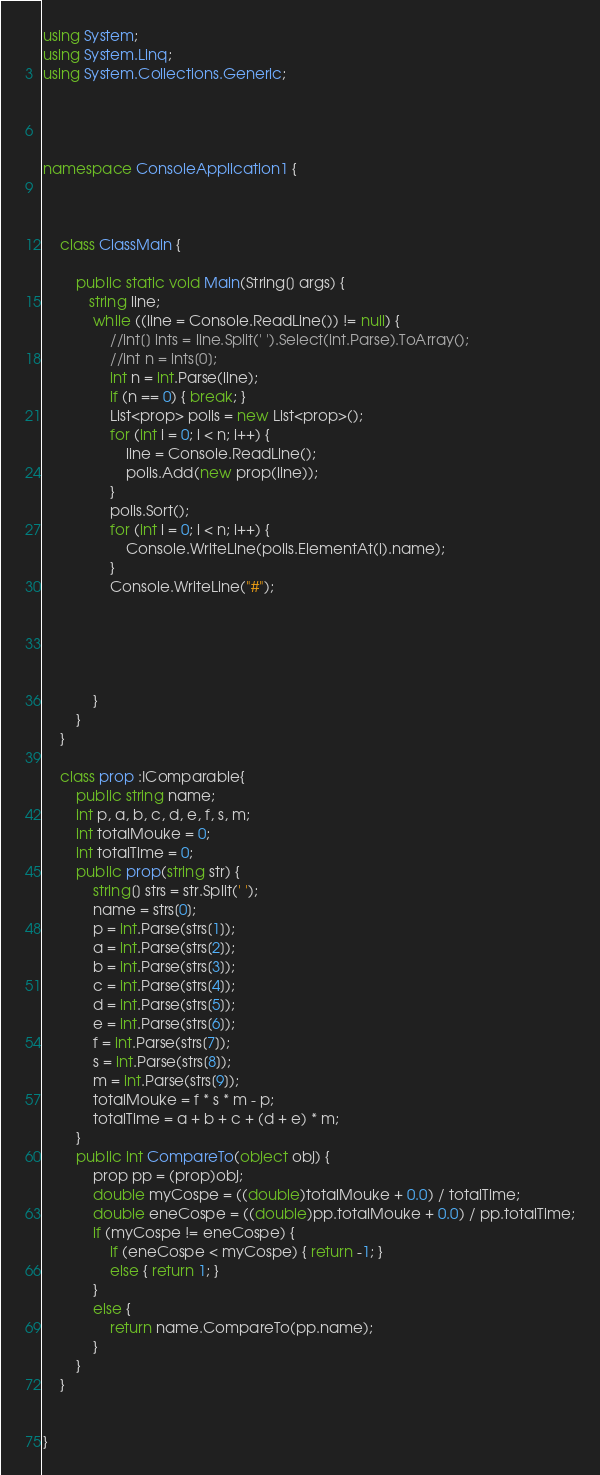Convert code to text. <code><loc_0><loc_0><loc_500><loc_500><_C#_>using System;
using System.Linq;
using System.Collections.Generic;




namespace ConsoleApplication1 {

    

    class ClassMain {

        public static void Main(String[] args) {
           string line;
            while ((line = Console.ReadLine()) != null) {
                //int[] ints = line.Split(' ').Select(int.Parse).ToArray();
                //int n = ints[0];
                int n = int.Parse(line);                
                if (n == 0) { break; }
                List<prop> polis = new List<prop>();
                for (int i = 0; i < n; i++) {
                    line = Console.ReadLine();
                    polis.Add(new prop(line));
                }
                polis.Sort();
                for (int i = 0; i < n; i++) {
                    Console.WriteLine(polis.ElementAt(i).name);
                }
                Console.WriteLine("#");
                    
                



            }
        }
    }

    class prop :IComparable{
        public string name;
        int p, a, b, c, d, e, f, s, m;
        int totalMouke = 0;
        int totalTime = 0;
        public prop(string str) {
            string[] strs = str.Split(' ');
            name = strs[0];
            p = int.Parse(strs[1]);
            a = int.Parse(strs[2]);
            b = int.Parse(strs[3]);
            c = int.Parse(strs[4]);
            d = int.Parse(strs[5]);
            e = int.Parse(strs[6]);
            f = int.Parse(strs[7]);
            s = int.Parse(strs[8]);
            m = int.Parse(strs[9]);
            totalMouke = f * s * m - p;
            totalTime = a + b + c + (d + e) * m;
        }
        public int CompareTo(object obj) {
            prop pp = (prop)obj;
            double myCospe = ((double)totalMouke + 0.0) / totalTime;
            double eneCospe = ((double)pp.totalMouke + 0.0) / pp.totalTime;
            if (myCospe != eneCospe) {
                if (eneCospe < myCospe) { return -1; }
                else { return 1; }
            }
            else {
                return name.CompareTo(pp.name);
            }
        }
    }


}</code> 